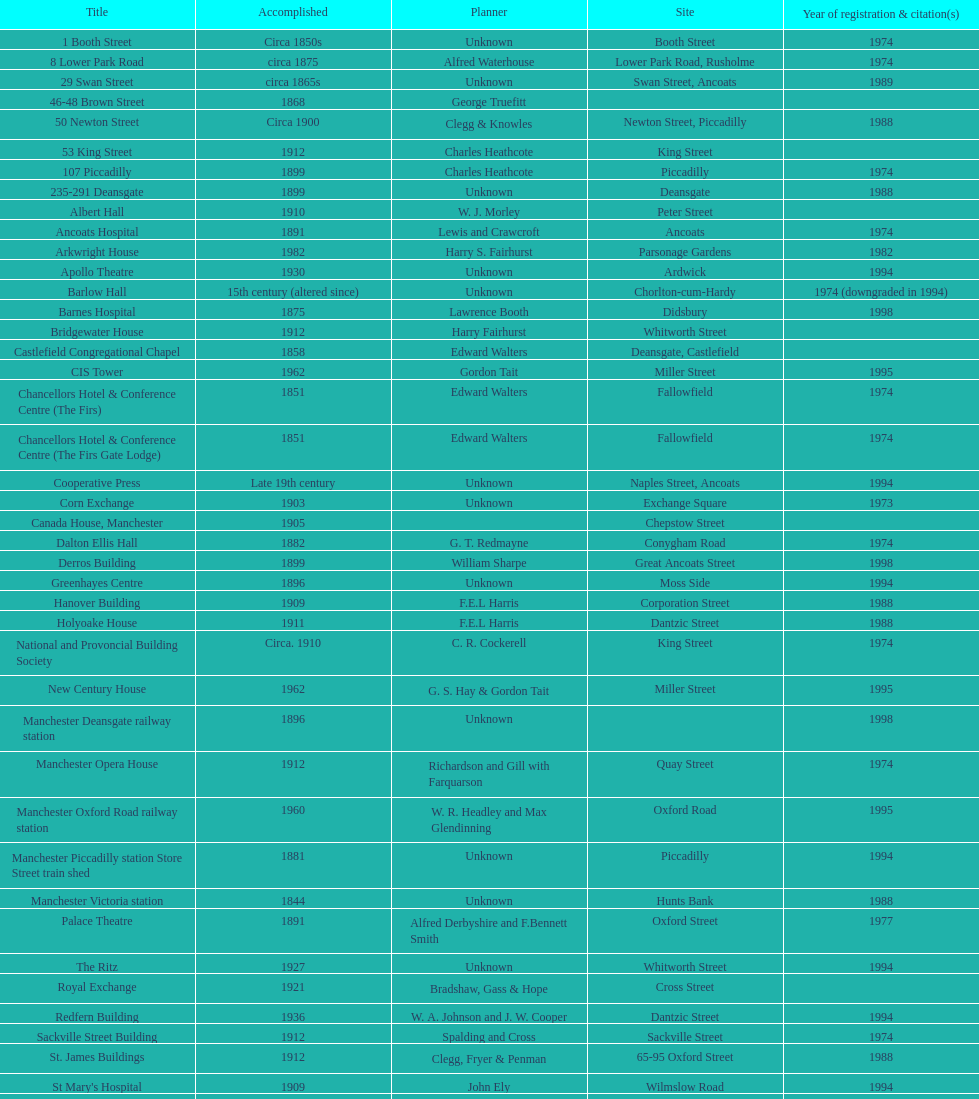How many buildings do not have an image listed? 11. 